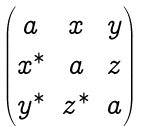<formula> <loc_0><loc_0><loc_500><loc_500>\begin{pmatrix} a & x & y \\ x ^ { * } & a & z \\ y ^ { * } & z ^ { * } & a \end{pmatrix}</formula> 